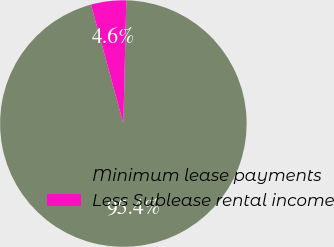Convert chart to OTSL. <chart><loc_0><loc_0><loc_500><loc_500><pie_chart><fcel>Minimum lease payments<fcel>Less Sublease rental income<nl><fcel>95.39%<fcel>4.61%<nl></chart> 